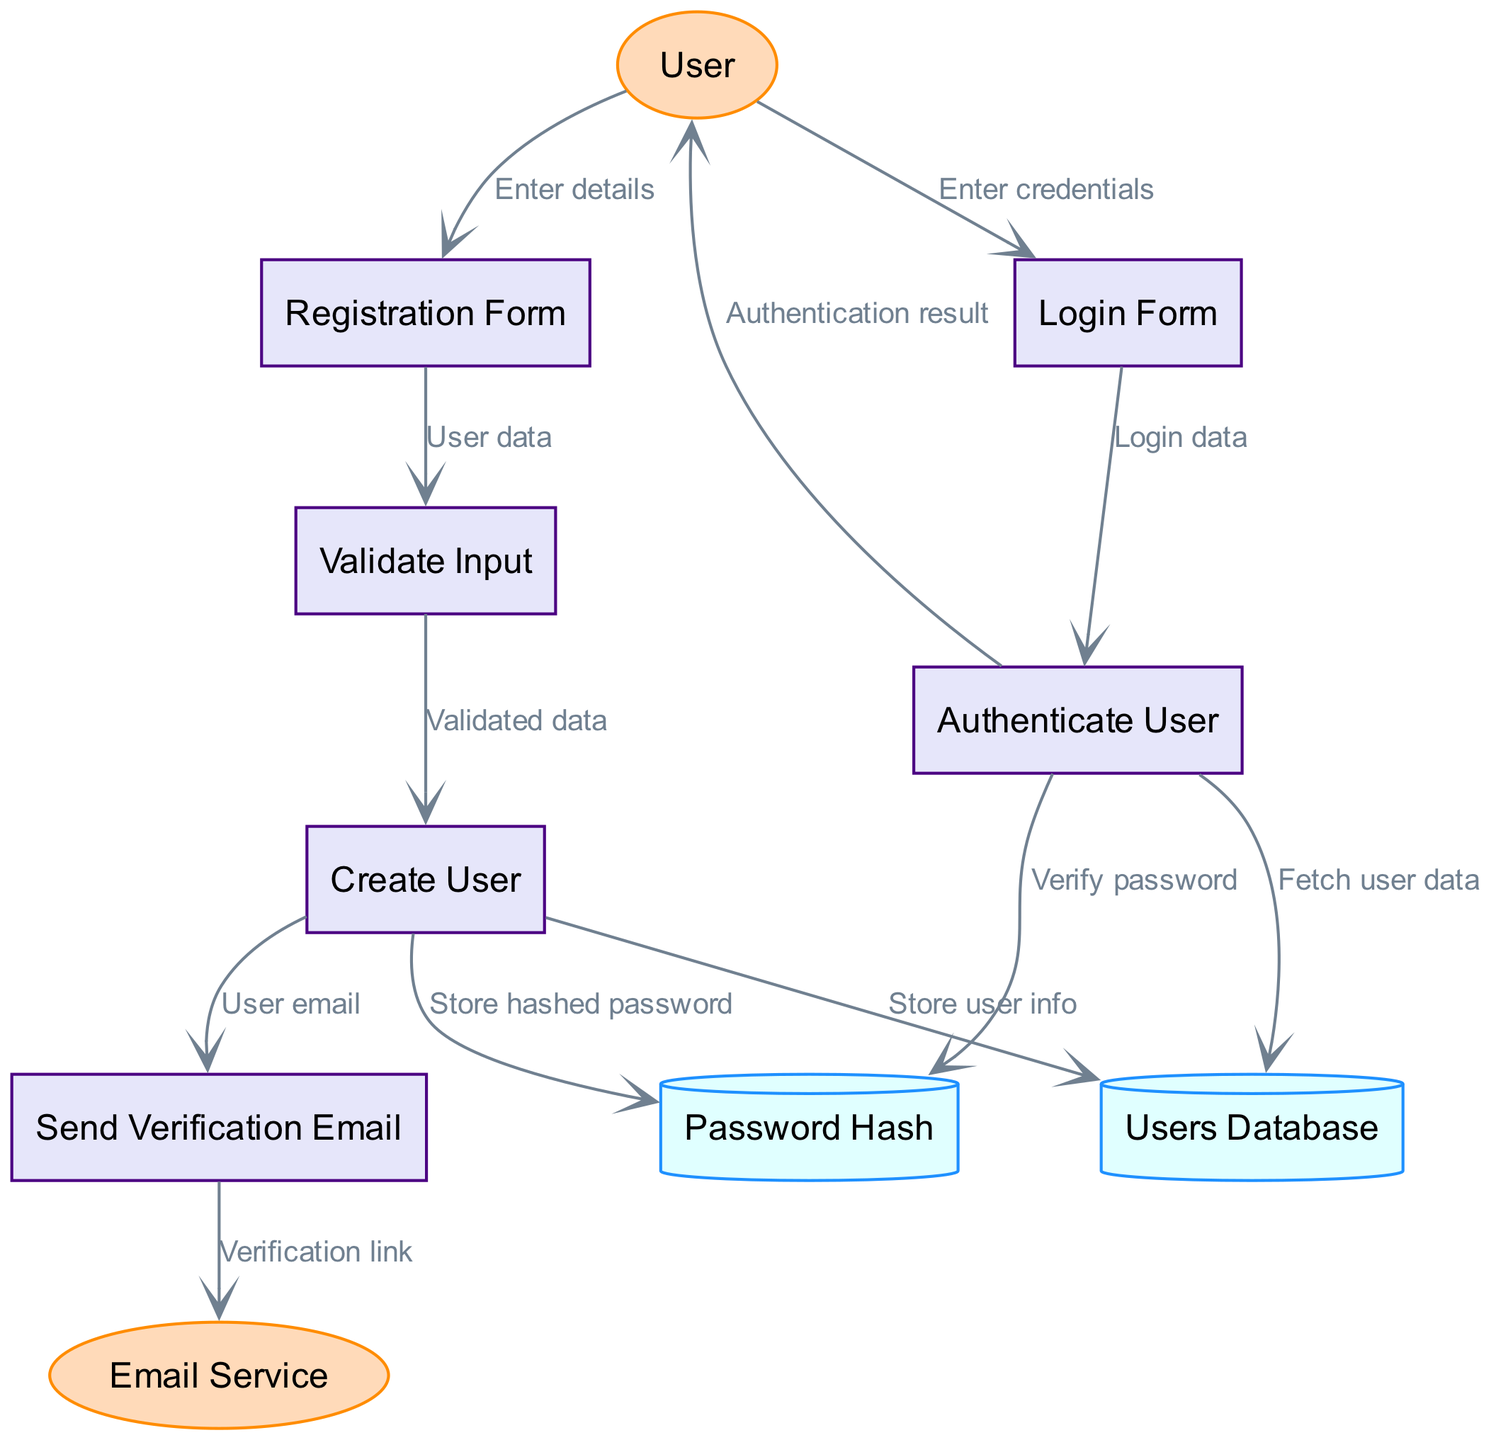What external entities are involved in the flow? The diagram shows two external entities: User and Email Service. These entities are represented in elliptical shapes indicating their role in the processes.
Answer: User, Email Service How many processes are listed in the diagram? There are six identified processes in the diagram related to user registration and authentication. The processes are Registration Form, Validate Input, Create User, Send Verification Email, Login Form, and Authenticate User.
Answer: 6 What data flow comes from the Registration Form? The flow from the Registration Form leads to the Validate Input process, where user data is sent for validation, as indicated by the label 'User data' on the arrow connecting these two nodes.
Answer: User data Which data store receives the hashed password? The Password Hash data store receives the hashed password from the Create User process, as depicted in the diagram. This is shown by a directed edge labelled 'Store hashed password'.
Answer: Password Hash What is the final outcome that the User receives after authentication? After the Authenticate User process checks credentials, the User receives the Authentication result, as indicated by the outgoing flow from the Authenticate User node.
Answer: Authentication result How does a User begin the registration process? The User starts the registration process by entering their details into the Registration Form, which is represented by the data flow labelled 'Enter details' from User to the Registration Form node.
Answer: Enter details How many data stores are depicted in the diagram? There are two data stores shown in the diagram: Users Database and Password Hash, which are used to store user information and hashed passwords, respectively.
Answer: 2 What triggers the Send Verification Email process? The Send Verification Email process is triggered by the 'User email' data flow from the Create User process, indicating that the user's email is passed to this process for sending a verification link.
Answer: User email What validates the user's credentials during the login process? The Authenticate User process is responsible for validating the user's credentials, as it fetches user data and verifies the password against the Password Hash data store. This is shown by the relationships between these nodes in the diagram.
Answer: Authenticate User 